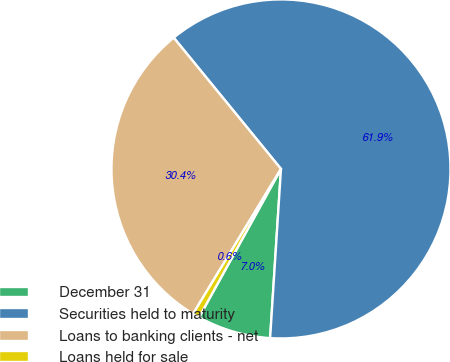Convert chart to OTSL. <chart><loc_0><loc_0><loc_500><loc_500><pie_chart><fcel>December 31<fcel>Securities held to maturity<fcel>Loans to banking clients - net<fcel>Loans held for sale<nl><fcel>7.01%<fcel>61.93%<fcel>30.42%<fcel>0.65%<nl></chart> 